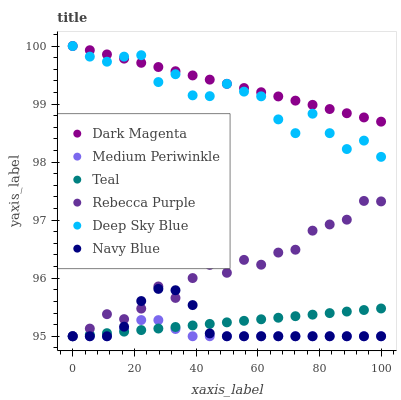Does Medium Periwinkle have the minimum area under the curve?
Answer yes or no. Yes. Does Dark Magenta have the maximum area under the curve?
Answer yes or no. Yes. Does Navy Blue have the minimum area under the curve?
Answer yes or no. No. Does Navy Blue have the maximum area under the curve?
Answer yes or no. No. Is Dark Magenta the smoothest?
Answer yes or no. Yes. Is Deep Sky Blue the roughest?
Answer yes or no. Yes. Is Navy Blue the smoothest?
Answer yes or no. No. Is Navy Blue the roughest?
Answer yes or no. No. Does Teal have the lowest value?
Answer yes or no. Yes. Does Dark Magenta have the lowest value?
Answer yes or no. No. Does Deep Sky Blue have the highest value?
Answer yes or no. Yes. Does Navy Blue have the highest value?
Answer yes or no. No. Is Navy Blue less than Dark Magenta?
Answer yes or no. Yes. Is Deep Sky Blue greater than Medium Periwinkle?
Answer yes or no. Yes. Does Navy Blue intersect Teal?
Answer yes or no. Yes. Is Navy Blue less than Teal?
Answer yes or no. No. Is Navy Blue greater than Teal?
Answer yes or no. No. Does Navy Blue intersect Dark Magenta?
Answer yes or no. No. 